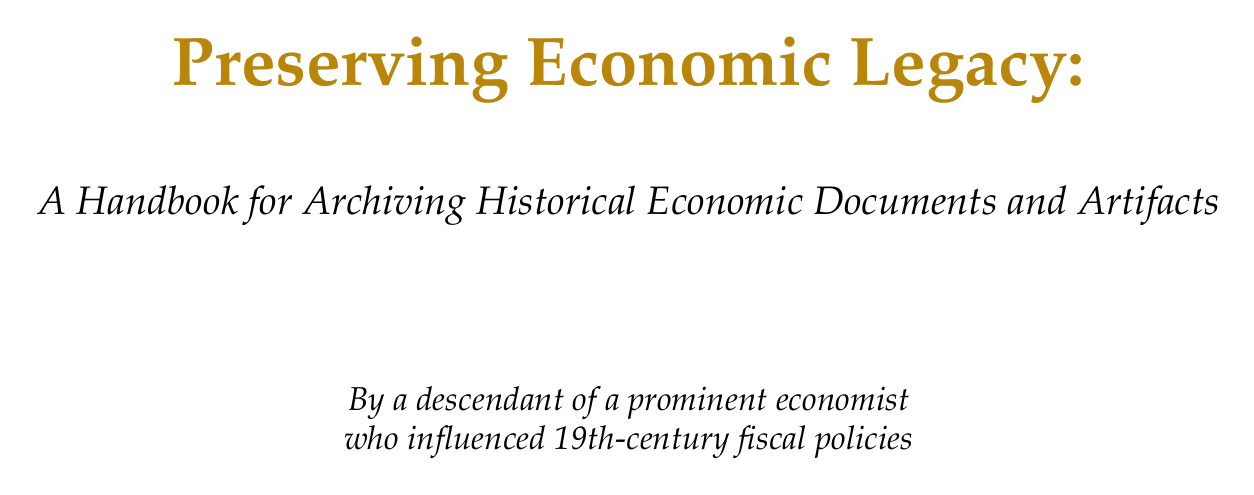what is the title of the handbook? The title of the handbook is given at the beginning of the document.
Answer: Preserving Economic Legacy: A Handbook for Archiving Historical Economic Documents and Artifacts who is the intended audience for the handbook? The introduction specifies the readers for whom the handbook is written.
Answer: A descendant of a prominent 19th-century economist what section covers methods for preserving fragile paper documents? The chapter titled "Document Preservation Techniques" has a section specifically about this.
Answer: Paper Conservation which institution's methods are referenced for digitizing economic papers? The handbook cites the Adam Smith Society's practices for this purpose.
Answer: Adam Smith Society what kind of artifacts does the "Artifact Preservation" chapter focus on? The chapter focuses on artifacts relevant to economic history, as specified in its title.
Answer: Currency and financial instruments what are the two main considerations discussed in the "Legal and Ethical Considerations" section? The section outlines two main aspects related to archiving in the document.
Answer: Copyright and privacy which professional organization is mentioned in the appendices? The appendices include a directory of professional organizations relevant to the field.
Answer: Society of American Archivists what kind of emergencies does the "Emergency Response" section address? The protocols in this section concern specific challenges faced by archived materials during incidents.
Answer: Emergencies affecting archived materials 